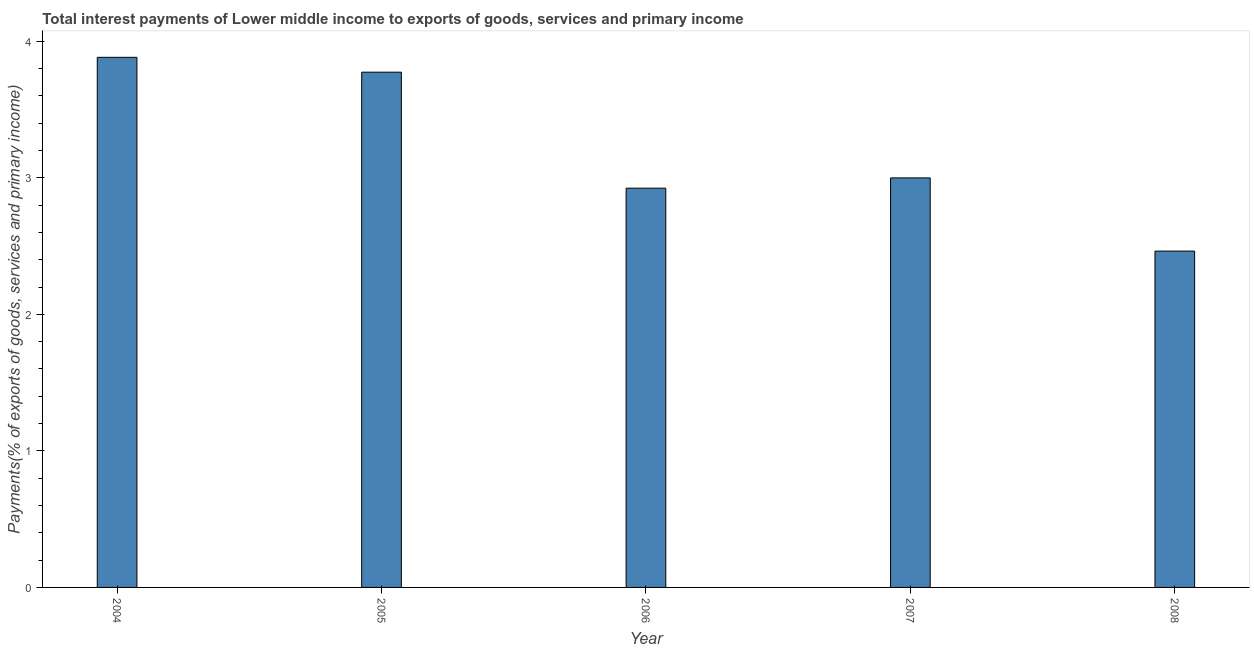Does the graph contain grids?
Provide a succinct answer. No. What is the title of the graph?
Your answer should be compact. Total interest payments of Lower middle income to exports of goods, services and primary income. What is the label or title of the Y-axis?
Offer a terse response. Payments(% of exports of goods, services and primary income). What is the total interest payments on external debt in 2006?
Provide a succinct answer. 2.92. Across all years, what is the maximum total interest payments on external debt?
Your answer should be very brief. 3.88. Across all years, what is the minimum total interest payments on external debt?
Ensure brevity in your answer.  2.46. What is the sum of the total interest payments on external debt?
Your answer should be compact. 16.04. What is the difference between the total interest payments on external debt in 2005 and 2008?
Offer a very short reply. 1.31. What is the average total interest payments on external debt per year?
Your answer should be very brief. 3.21. What is the median total interest payments on external debt?
Ensure brevity in your answer.  3. What is the ratio of the total interest payments on external debt in 2004 to that in 2006?
Offer a very short reply. 1.33. Is the difference between the total interest payments on external debt in 2005 and 2006 greater than the difference between any two years?
Offer a very short reply. No. What is the difference between the highest and the second highest total interest payments on external debt?
Offer a very short reply. 0.11. Is the sum of the total interest payments on external debt in 2004 and 2006 greater than the maximum total interest payments on external debt across all years?
Offer a very short reply. Yes. What is the difference between the highest and the lowest total interest payments on external debt?
Give a very brief answer. 1.42. Are all the bars in the graph horizontal?
Offer a terse response. No. How many years are there in the graph?
Ensure brevity in your answer.  5. What is the Payments(% of exports of goods, services and primary income) of 2004?
Provide a short and direct response. 3.88. What is the Payments(% of exports of goods, services and primary income) in 2005?
Your response must be concise. 3.77. What is the Payments(% of exports of goods, services and primary income) of 2006?
Keep it short and to the point. 2.92. What is the Payments(% of exports of goods, services and primary income) of 2007?
Your response must be concise. 3. What is the Payments(% of exports of goods, services and primary income) of 2008?
Provide a succinct answer. 2.46. What is the difference between the Payments(% of exports of goods, services and primary income) in 2004 and 2005?
Ensure brevity in your answer.  0.11. What is the difference between the Payments(% of exports of goods, services and primary income) in 2004 and 2006?
Offer a very short reply. 0.96. What is the difference between the Payments(% of exports of goods, services and primary income) in 2004 and 2007?
Offer a very short reply. 0.88. What is the difference between the Payments(% of exports of goods, services and primary income) in 2004 and 2008?
Keep it short and to the point. 1.42. What is the difference between the Payments(% of exports of goods, services and primary income) in 2005 and 2006?
Offer a terse response. 0.85. What is the difference between the Payments(% of exports of goods, services and primary income) in 2005 and 2007?
Your answer should be very brief. 0.77. What is the difference between the Payments(% of exports of goods, services and primary income) in 2005 and 2008?
Provide a succinct answer. 1.31. What is the difference between the Payments(% of exports of goods, services and primary income) in 2006 and 2007?
Provide a succinct answer. -0.08. What is the difference between the Payments(% of exports of goods, services and primary income) in 2006 and 2008?
Give a very brief answer. 0.46. What is the difference between the Payments(% of exports of goods, services and primary income) in 2007 and 2008?
Ensure brevity in your answer.  0.54. What is the ratio of the Payments(% of exports of goods, services and primary income) in 2004 to that in 2005?
Your answer should be very brief. 1.03. What is the ratio of the Payments(% of exports of goods, services and primary income) in 2004 to that in 2006?
Make the answer very short. 1.33. What is the ratio of the Payments(% of exports of goods, services and primary income) in 2004 to that in 2007?
Ensure brevity in your answer.  1.29. What is the ratio of the Payments(% of exports of goods, services and primary income) in 2004 to that in 2008?
Ensure brevity in your answer.  1.58. What is the ratio of the Payments(% of exports of goods, services and primary income) in 2005 to that in 2006?
Offer a very short reply. 1.29. What is the ratio of the Payments(% of exports of goods, services and primary income) in 2005 to that in 2007?
Your answer should be very brief. 1.26. What is the ratio of the Payments(% of exports of goods, services and primary income) in 2005 to that in 2008?
Offer a terse response. 1.53. What is the ratio of the Payments(% of exports of goods, services and primary income) in 2006 to that in 2007?
Provide a succinct answer. 0.97. What is the ratio of the Payments(% of exports of goods, services and primary income) in 2006 to that in 2008?
Your answer should be compact. 1.19. What is the ratio of the Payments(% of exports of goods, services and primary income) in 2007 to that in 2008?
Ensure brevity in your answer.  1.22. 